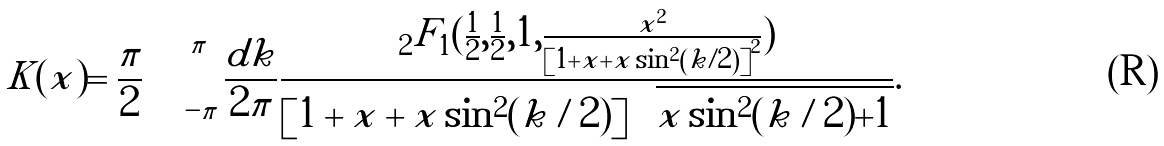<formula> <loc_0><loc_0><loc_500><loc_500>K ( x ) = \frac { \pi } { 2 } \int _ { - \pi } ^ { \pi } \frac { d k } { 2 \pi } \frac { _ { 2 } F _ { 1 } ( \frac { 1 } { 2 } , \frac { 1 } { 2 } , 1 , \frac { x ^ { 2 } } { \left [ 1 + x + x \sin ^ { 2 } \left ( k / 2 \right ) \right ] ^ { 2 } } ) } { \left [ 1 + x + x \sin ^ { 2 } ( k / 2 ) \right ] \sqrt { x \sin ^ { 2 } ( k / 2 ) + 1 } } .</formula> 